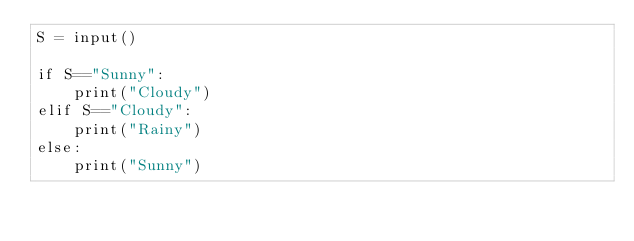Convert code to text. <code><loc_0><loc_0><loc_500><loc_500><_Python_>S = input()

if S=="Sunny":
    print("Cloudy")
elif S=="Cloudy":
    print("Rainy")
else:
    print("Sunny")</code> 